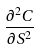<formula> <loc_0><loc_0><loc_500><loc_500>\frac { \partial ^ { 2 } C } { \partial S ^ { 2 } }</formula> 